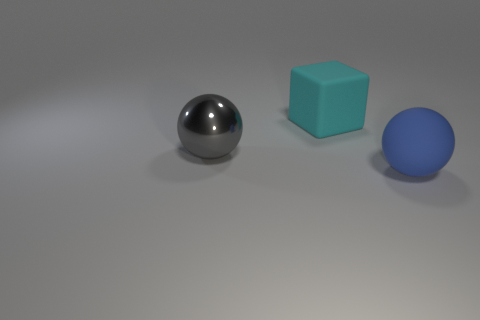Add 3 big blue rubber spheres. How many objects exist? 6 Subtract all blue spheres. How many spheres are left? 1 Subtract all large blue rubber things. Subtract all big blue matte objects. How many objects are left? 1 Add 1 matte cubes. How many matte cubes are left? 2 Add 2 big cyan shiny cylinders. How many big cyan shiny cylinders exist? 2 Subtract 0 purple spheres. How many objects are left? 3 Subtract all blocks. How many objects are left? 2 Subtract 1 balls. How many balls are left? 1 Subtract all blue balls. Subtract all red cylinders. How many balls are left? 1 